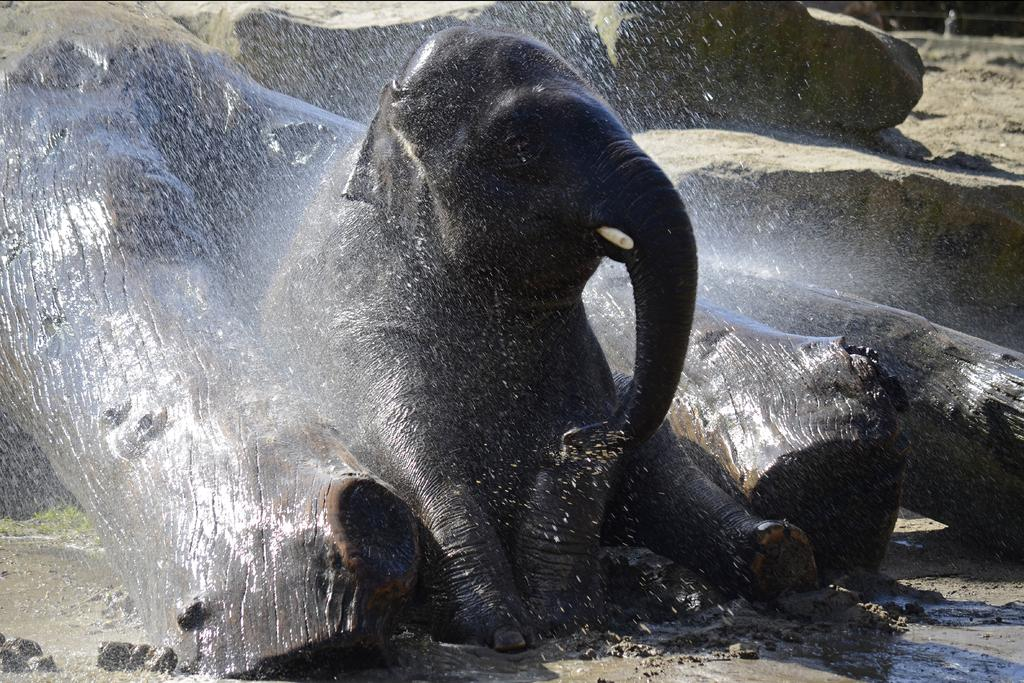What animal is present in the image? There is an elephant in the image. What objects can be seen near the elephant? There are wooden logs in the image. What is happening with the water in the image? There is a shower of water in the image. What type of natural feature can be seen in the background? There are rocks visible in the background of the image. Where is the donkey wearing a crown in the image? There is no donkey or crown present in the image. 